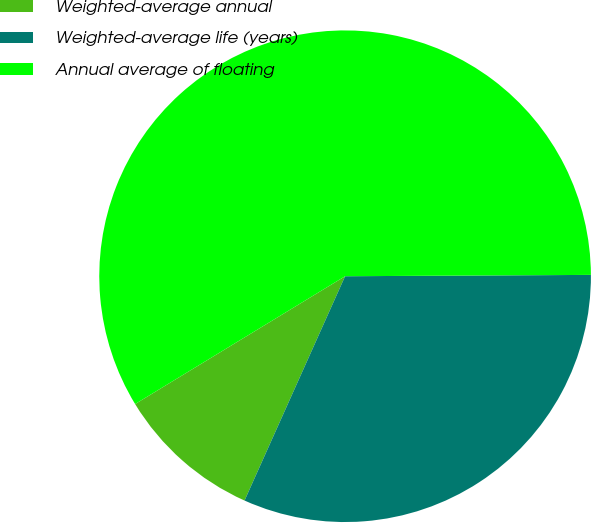<chart> <loc_0><loc_0><loc_500><loc_500><pie_chart><fcel>Weighted-average annual<fcel>Weighted-average life (years)<fcel>Annual average of floating<nl><fcel>9.59%<fcel>31.79%<fcel>58.61%<nl></chart> 